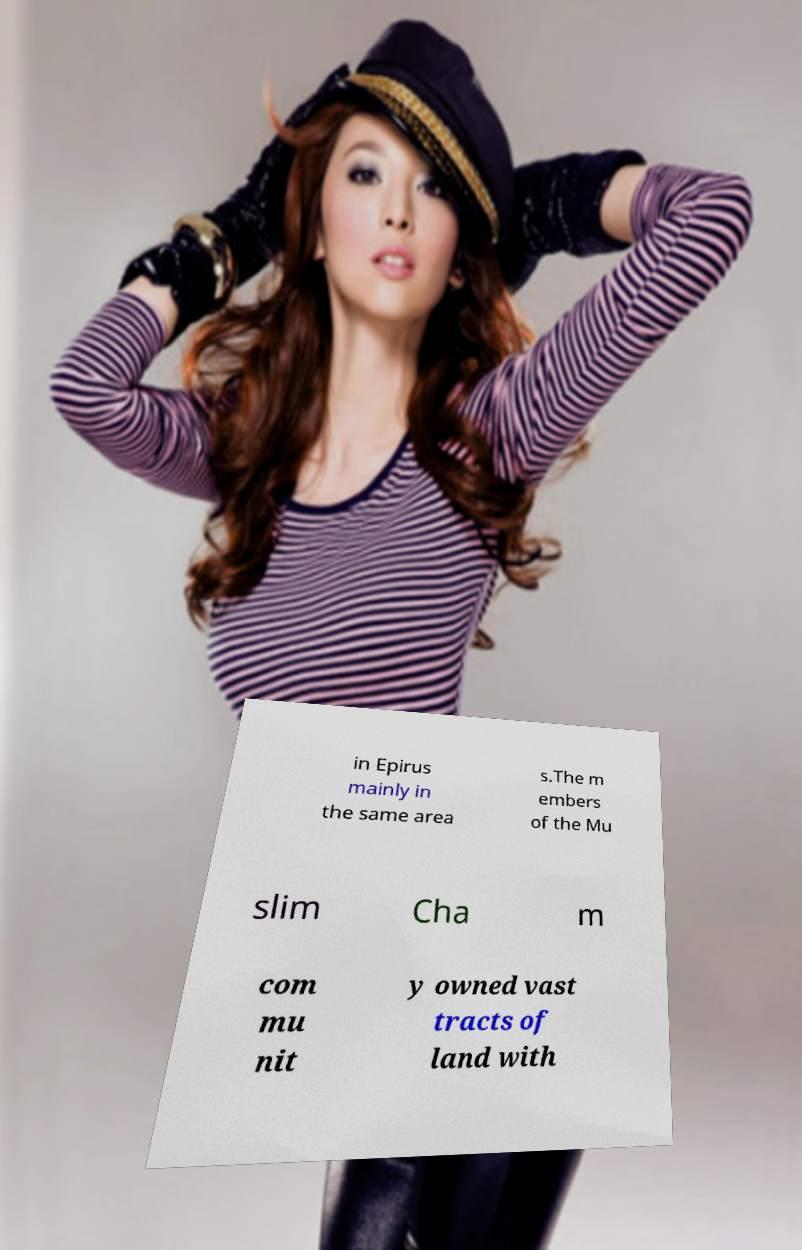What messages or text are displayed in this image? I need them in a readable, typed format. in Epirus mainly in the same area s.The m embers of the Mu slim Cha m com mu nit y owned vast tracts of land with 